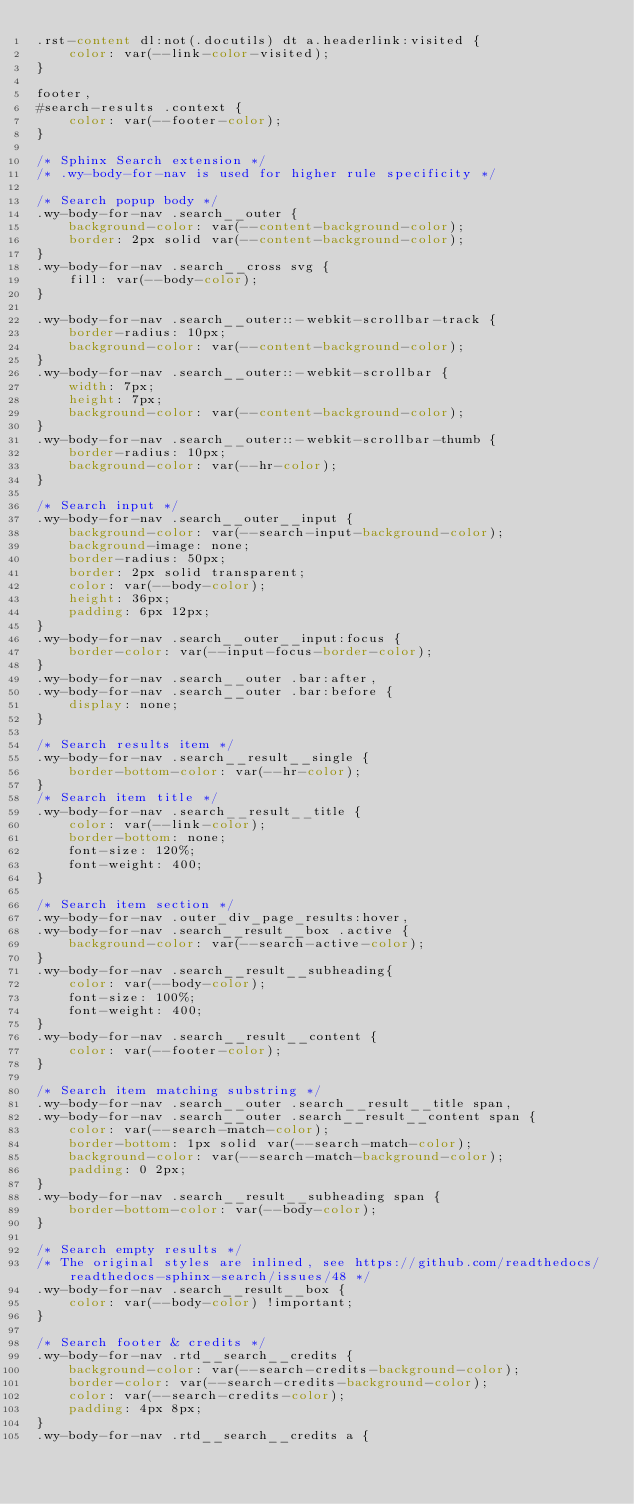<code> <loc_0><loc_0><loc_500><loc_500><_CSS_>.rst-content dl:not(.docutils) dt a.headerlink:visited {
    color: var(--link-color-visited);
}

footer,
#search-results .context {
    color: var(--footer-color);
}

/* Sphinx Search extension */
/* .wy-body-for-nav is used for higher rule specificity */

/* Search popup body */
.wy-body-for-nav .search__outer {
    background-color: var(--content-background-color);
    border: 2px solid var(--content-background-color);
}
.wy-body-for-nav .search__cross svg {
    fill: var(--body-color);
}

.wy-body-for-nav .search__outer::-webkit-scrollbar-track {
    border-radius: 10px;
    background-color: var(--content-background-color);
}
.wy-body-for-nav .search__outer::-webkit-scrollbar {
    width: 7px;
    height: 7px;
    background-color: var(--content-background-color);
}
.wy-body-for-nav .search__outer::-webkit-scrollbar-thumb {
    border-radius: 10px;
    background-color: var(--hr-color);
}

/* Search input */
.wy-body-for-nav .search__outer__input {
    background-color: var(--search-input-background-color);
    background-image: none;
    border-radius: 50px;
    border: 2px solid transparent;
    color: var(--body-color);
    height: 36px;
    padding: 6px 12px;
}
.wy-body-for-nav .search__outer__input:focus {
    border-color: var(--input-focus-border-color);
}
.wy-body-for-nav .search__outer .bar:after,
.wy-body-for-nav .search__outer .bar:before {
    display: none;
}

/* Search results item */
.wy-body-for-nav .search__result__single {
    border-bottom-color: var(--hr-color);
}
/* Search item title */
.wy-body-for-nav .search__result__title {
    color: var(--link-color);
    border-bottom: none;
    font-size: 120%;
    font-weight: 400;
}

/* Search item section */
.wy-body-for-nav .outer_div_page_results:hover,
.wy-body-for-nav .search__result__box .active {
    background-color: var(--search-active-color);
}
.wy-body-for-nav .search__result__subheading{
    color: var(--body-color);
    font-size: 100%;
    font-weight: 400;
}
.wy-body-for-nav .search__result__content {
    color: var(--footer-color);
}

/* Search item matching substring */
.wy-body-for-nav .search__outer .search__result__title span,
.wy-body-for-nav .search__outer .search__result__content span {
    color: var(--search-match-color);
    border-bottom: 1px solid var(--search-match-color);
    background-color: var(--search-match-background-color);
    padding: 0 2px;
}
.wy-body-for-nav .search__result__subheading span {
    border-bottom-color: var(--body-color);
}

/* Search empty results */
/* The original styles are inlined, see https://github.com/readthedocs/readthedocs-sphinx-search/issues/48 */
.wy-body-for-nav .search__result__box {
    color: var(--body-color) !important;
}

/* Search footer & credits */
.wy-body-for-nav .rtd__search__credits {
    background-color: var(--search-credits-background-color);
    border-color: var(--search-credits-background-color);
    color: var(--search-credits-color);
    padding: 4px 8px;
}
.wy-body-for-nav .rtd__search__credits a {</code> 